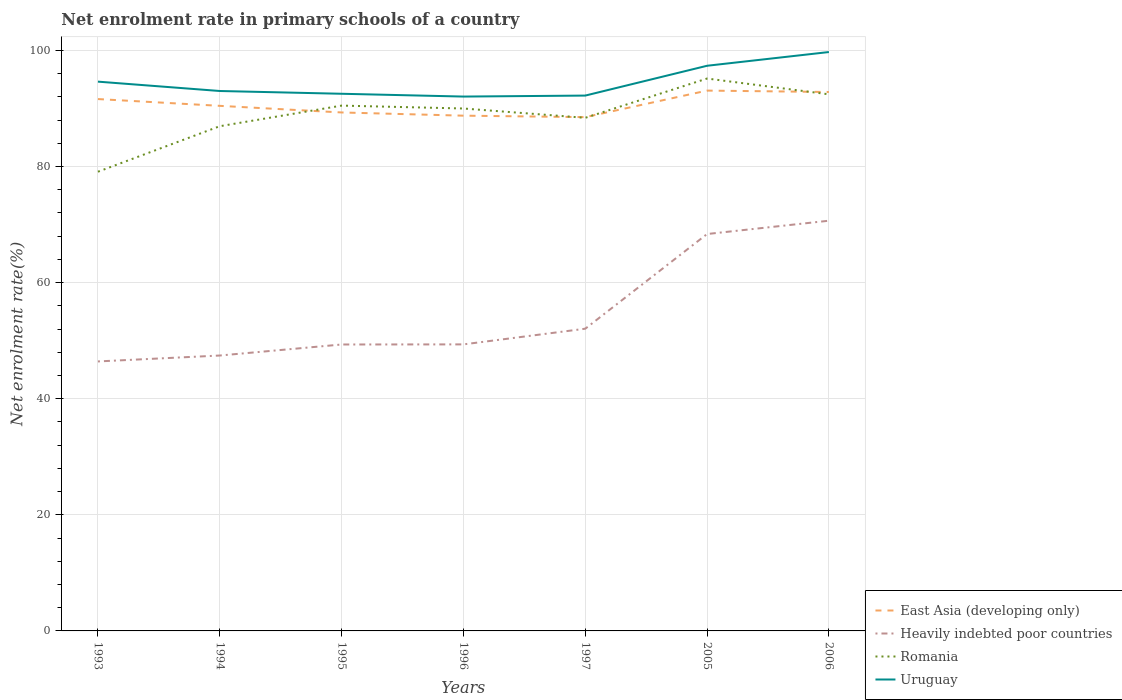How many different coloured lines are there?
Offer a very short reply. 4. Across all years, what is the maximum net enrolment rate in primary schools in Romania?
Offer a very short reply. 79.11. In which year was the net enrolment rate in primary schools in Heavily indebted poor countries maximum?
Ensure brevity in your answer.  1993. What is the total net enrolment rate in primary schools in Heavily indebted poor countries in the graph?
Offer a terse response. -1.9. What is the difference between the highest and the second highest net enrolment rate in primary schools in Uruguay?
Make the answer very short. 7.67. What is the difference between the highest and the lowest net enrolment rate in primary schools in Romania?
Your answer should be compact. 4. What is the difference between two consecutive major ticks on the Y-axis?
Offer a terse response. 20. Are the values on the major ticks of Y-axis written in scientific E-notation?
Provide a short and direct response. No. Does the graph contain grids?
Give a very brief answer. Yes. What is the title of the graph?
Your answer should be very brief. Net enrolment rate in primary schools of a country. Does "Latin America(all income levels)" appear as one of the legend labels in the graph?
Give a very brief answer. No. What is the label or title of the X-axis?
Your answer should be very brief. Years. What is the label or title of the Y-axis?
Your answer should be compact. Net enrolment rate(%). What is the Net enrolment rate(%) of East Asia (developing only) in 1993?
Keep it short and to the point. 91.63. What is the Net enrolment rate(%) of Heavily indebted poor countries in 1993?
Your response must be concise. 46.43. What is the Net enrolment rate(%) of Romania in 1993?
Keep it short and to the point. 79.11. What is the Net enrolment rate(%) of Uruguay in 1993?
Offer a very short reply. 94.63. What is the Net enrolment rate(%) in East Asia (developing only) in 1994?
Make the answer very short. 90.46. What is the Net enrolment rate(%) of Heavily indebted poor countries in 1994?
Your answer should be compact. 47.45. What is the Net enrolment rate(%) of Romania in 1994?
Your response must be concise. 86.95. What is the Net enrolment rate(%) in Uruguay in 1994?
Your response must be concise. 93.01. What is the Net enrolment rate(%) in East Asia (developing only) in 1995?
Give a very brief answer. 89.32. What is the Net enrolment rate(%) of Heavily indebted poor countries in 1995?
Keep it short and to the point. 49.34. What is the Net enrolment rate(%) in Romania in 1995?
Provide a succinct answer. 90.5. What is the Net enrolment rate(%) of Uruguay in 1995?
Your response must be concise. 92.54. What is the Net enrolment rate(%) in East Asia (developing only) in 1996?
Give a very brief answer. 88.77. What is the Net enrolment rate(%) in Heavily indebted poor countries in 1996?
Give a very brief answer. 49.36. What is the Net enrolment rate(%) in Romania in 1996?
Ensure brevity in your answer.  90. What is the Net enrolment rate(%) in Uruguay in 1996?
Give a very brief answer. 92.06. What is the Net enrolment rate(%) in East Asia (developing only) in 1997?
Offer a very short reply. 88.51. What is the Net enrolment rate(%) in Heavily indebted poor countries in 1997?
Provide a succinct answer. 52.06. What is the Net enrolment rate(%) of Romania in 1997?
Keep it short and to the point. 88.39. What is the Net enrolment rate(%) of Uruguay in 1997?
Make the answer very short. 92.22. What is the Net enrolment rate(%) of East Asia (developing only) in 2005?
Provide a succinct answer. 93.09. What is the Net enrolment rate(%) in Heavily indebted poor countries in 2005?
Give a very brief answer. 68.38. What is the Net enrolment rate(%) in Romania in 2005?
Ensure brevity in your answer.  95.16. What is the Net enrolment rate(%) in Uruguay in 2005?
Your answer should be very brief. 97.36. What is the Net enrolment rate(%) in East Asia (developing only) in 2006?
Offer a very short reply. 92.84. What is the Net enrolment rate(%) in Heavily indebted poor countries in 2006?
Your answer should be compact. 70.67. What is the Net enrolment rate(%) of Romania in 2006?
Your answer should be compact. 92.44. What is the Net enrolment rate(%) of Uruguay in 2006?
Your answer should be compact. 99.73. Across all years, what is the maximum Net enrolment rate(%) in East Asia (developing only)?
Make the answer very short. 93.09. Across all years, what is the maximum Net enrolment rate(%) in Heavily indebted poor countries?
Offer a very short reply. 70.67. Across all years, what is the maximum Net enrolment rate(%) of Romania?
Your answer should be very brief. 95.16. Across all years, what is the maximum Net enrolment rate(%) in Uruguay?
Offer a terse response. 99.73. Across all years, what is the minimum Net enrolment rate(%) of East Asia (developing only)?
Give a very brief answer. 88.51. Across all years, what is the minimum Net enrolment rate(%) in Heavily indebted poor countries?
Keep it short and to the point. 46.43. Across all years, what is the minimum Net enrolment rate(%) in Romania?
Offer a terse response. 79.11. Across all years, what is the minimum Net enrolment rate(%) of Uruguay?
Your response must be concise. 92.06. What is the total Net enrolment rate(%) of East Asia (developing only) in the graph?
Ensure brevity in your answer.  634.61. What is the total Net enrolment rate(%) in Heavily indebted poor countries in the graph?
Provide a short and direct response. 383.68. What is the total Net enrolment rate(%) in Romania in the graph?
Offer a terse response. 622.55. What is the total Net enrolment rate(%) in Uruguay in the graph?
Ensure brevity in your answer.  661.55. What is the difference between the Net enrolment rate(%) in East Asia (developing only) in 1993 and that in 1994?
Make the answer very short. 1.17. What is the difference between the Net enrolment rate(%) in Heavily indebted poor countries in 1993 and that in 1994?
Your response must be concise. -1.02. What is the difference between the Net enrolment rate(%) of Romania in 1993 and that in 1994?
Your answer should be very brief. -7.84. What is the difference between the Net enrolment rate(%) in Uruguay in 1993 and that in 1994?
Make the answer very short. 1.61. What is the difference between the Net enrolment rate(%) of East Asia (developing only) in 1993 and that in 1995?
Offer a very short reply. 2.31. What is the difference between the Net enrolment rate(%) of Heavily indebted poor countries in 1993 and that in 1995?
Offer a terse response. -2.92. What is the difference between the Net enrolment rate(%) of Romania in 1993 and that in 1995?
Offer a terse response. -11.39. What is the difference between the Net enrolment rate(%) in Uruguay in 1993 and that in 1995?
Give a very brief answer. 2.09. What is the difference between the Net enrolment rate(%) of East Asia (developing only) in 1993 and that in 1996?
Your response must be concise. 2.86. What is the difference between the Net enrolment rate(%) in Heavily indebted poor countries in 1993 and that in 1996?
Offer a terse response. -2.94. What is the difference between the Net enrolment rate(%) of Romania in 1993 and that in 1996?
Your answer should be very brief. -10.89. What is the difference between the Net enrolment rate(%) in Uruguay in 1993 and that in 1996?
Offer a very short reply. 2.57. What is the difference between the Net enrolment rate(%) of East Asia (developing only) in 1993 and that in 1997?
Offer a very short reply. 3.11. What is the difference between the Net enrolment rate(%) in Heavily indebted poor countries in 1993 and that in 1997?
Offer a terse response. -5.64. What is the difference between the Net enrolment rate(%) in Romania in 1993 and that in 1997?
Keep it short and to the point. -9.29. What is the difference between the Net enrolment rate(%) of Uruguay in 1993 and that in 1997?
Provide a succinct answer. 2.4. What is the difference between the Net enrolment rate(%) of East Asia (developing only) in 1993 and that in 2005?
Offer a terse response. -1.46. What is the difference between the Net enrolment rate(%) in Heavily indebted poor countries in 1993 and that in 2005?
Give a very brief answer. -21.95. What is the difference between the Net enrolment rate(%) in Romania in 1993 and that in 2005?
Provide a short and direct response. -16.05. What is the difference between the Net enrolment rate(%) in Uruguay in 1993 and that in 2005?
Provide a succinct answer. -2.74. What is the difference between the Net enrolment rate(%) in East Asia (developing only) in 1993 and that in 2006?
Give a very brief answer. -1.22. What is the difference between the Net enrolment rate(%) of Heavily indebted poor countries in 1993 and that in 2006?
Give a very brief answer. -24.24. What is the difference between the Net enrolment rate(%) in Romania in 1993 and that in 2006?
Ensure brevity in your answer.  -13.33. What is the difference between the Net enrolment rate(%) of Uruguay in 1993 and that in 2006?
Offer a terse response. -5.1. What is the difference between the Net enrolment rate(%) in East Asia (developing only) in 1994 and that in 1995?
Your answer should be very brief. 1.14. What is the difference between the Net enrolment rate(%) in Heavily indebted poor countries in 1994 and that in 1995?
Your answer should be compact. -1.9. What is the difference between the Net enrolment rate(%) of Romania in 1994 and that in 1995?
Give a very brief answer. -3.55. What is the difference between the Net enrolment rate(%) of Uruguay in 1994 and that in 1995?
Offer a terse response. 0.47. What is the difference between the Net enrolment rate(%) of East Asia (developing only) in 1994 and that in 1996?
Your answer should be very brief. 1.69. What is the difference between the Net enrolment rate(%) of Heavily indebted poor countries in 1994 and that in 1996?
Offer a terse response. -1.92. What is the difference between the Net enrolment rate(%) of Romania in 1994 and that in 1996?
Your response must be concise. -3.05. What is the difference between the Net enrolment rate(%) of Uruguay in 1994 and that in 1996?
Keep it short and to the point. 0.96. What is the difference between the Net enrolment rate(%) in East Asia (developing only) in 1994 and that in 1997?
Give a very brief answer. 1.95. What is the difference between the Net enrolment rate(%) of Heavily indebted poor countries in 1994 and that in 1997?
Offer a terse response. -4.62. What is the difference between the Net enrolment rate(%) of Romania in 1994 and that in 1997?
Provide a succinct answer. -1.45. What is the difference between the Net enrolment rate(%) of Uruguay in 1994 and that in 1997?
Provide a short and direct response. 0.79. What is the difference between the Net enrolment rate(%) in East Asia (developing only) in 1994 and that in 2005?
Offer a very short reply. -2.63. What is the difference between the Net enrolment rate(%) in Heavily indebted poor countries in 1994 and that in 2005?
Your response must be concise. -20.93. What is the difference between the Net enrolment rate(%) in Romania in 1994 and that in 2005?
Provide a succinct answer. -8.21. What is the difference between the Net enrolment rate(%) in Uruguay in 1994 and that in 2005?
Offer a very short reply. -4.35. What is the difference between the Net enrolment rate(%) of East Asia (developing only) in 1994 and that in 2006?
Provide a succinct answer. -2.39. What is the difference between the Net enrolment rate(%) of Heavily indebted poor countries in 1994 and that in 2006?
Your response must be concise. -23.22. What is the difference between the Net enrolment rate(%) in Romania in 1994 and that in 2006?
Make the answer very short. -5.49. What is the difference between the Net enrolment rate(%) of Uruguay in 1994 and that in 2006?
Offer a very short reply. -6.71. What is the difference between the Net enrolment rate(%) of East Asia (developing only) in 1995 and that in 1996?
Ensure brevity in your answer.  0.55. What is the difference between the Net enrolment rate(%) in Heavily indebted poor countries in 1995 and that in 1996?
Your answer should be very brief. -0.02. What is the difference between the Net enrolment rate(%) in Romania in 1995 and that in 1996?
Ensure brevity in your answer.  0.5. What is the difference between the Net enrolment rate(%) in Uruguay in 1995 and that in 1996?
Offer a very short reply. 0.48. What is the difference between the Net enrolment rate(%) in East Asia (developing only) in 1995 and that in 1997?
Make the answer very short. 0.81. What is the difference between the Net enrolment rate(%) of Heavily indebted poor countries in 1995 and that in 1997?
Provide a succinct answer. -2.72. What is the difference between the Net enrolment rate(%) in Romania in 1995 and that in 1997?
Give a very brief answer. 2.1. What is the difference between the Net enrolment rate(%) of Uruguay in 1995 and that in 1997?
Make the answer very short. 0.31. What is the difference between the Net enrolment rate(%) in East Asia (developing only) in 1995 and that in 2005?
Keep it short and to the point. -3.77. What is the difference between the Net enrolment rate(%) in Heavily indebted poor countries in 1995 and that in 2005?
Offer a terse response. -19.03. What is the difference between the Net enrolment rate(%) in Romania in 1995 and that in 2005?
Provide a short and direct response. -4.66. What is the difference between the Net enrolment rate(%) in Uruguay in 1995 and that in 2005?
Your response must be concise. -4.82. What is the difference between the Net enrolment rate(%) in East Asia (developing only) in 1995 and that in 2006?
Your answer should be compact. -3.53. What is the difference between the Net enrolment rate(%) of Heavily indebted poor countries in 1995 and that in 2006?
Give a very brief answer. -21.32. What is the difference between the Net enrolment rate(%) in Romania in 1995 and that in 2006?
Give a very brief answer. -1.94. What is the difference between the Net enrolment rate(%) in Uruguay in 1995 and that in 2006?
Give a very brief answer. -7.19. What is the difference between the Net enrolment rate(%) in East Asia (developing only) in 1996 and that in 1997?
Your answer should be compact. 0.25. What is the difference between the Net enrolment rate(%) of Heavily indebted poor countries in 1996 and that in 1997?
Provide a succinct answer. -2.7. What is the difference between the Net enrolment rate(%) in Romania in 1996 and that in 1997?
Provide a short and direct response. 1.61. What is the difference between the Net enrolment rate(%) of Uruguay in 1996 and that in 1997?
Provide a short and direct response. -0.17. What is the difference between the Net enrolment rate(%) in East Asia (developing only) in 1996 and that in 2005?
Offer a terse response. -4.32. What is the difference between the Net enrolment rate(%) in Heavily indebted poor countries in 1996 and that in 2005?
Keep it short and to the point. -19.01. What is the difference between the Net enrolment rate(%) of Romania in 1996 and that in 2005?
Your answer should be compact. -5.16. What is the difference between the Net enrolment rate(%) of Uruguay in 1996 and that in 2005?
Keep it short and to the point. -5.31. What is the difference between the Net enrolment rate(%) in East Asia (developing only) in 1996 and that in 2006?
Your answer should be compact. -4.08. What is the difference between the Net enrolment rate(%) of Heavily indebted poor countries in 1996 and that in 2006?
Make the answer very short. -21.3. What is the difference between the Net enrolment rate(%) of Romania in 1996 and that in 2006?
Provide a short and direct response. -2.44. What is the difference between the Net enrolment rate(%) of Uruguay in 1996 and that in 2006?
Keep it short and to the point. -7.67. What is the difference between the Net enrolment rate(%) in East Asia (developing only) in 1997 and that in 2005?
Provide a succinct answer. -4.57. What is the difference between the Net enrolment rate(%) of Heavily indebted poor countries in 1997 and that in 2005?
Your response must be concise. -16.31. What is the difference between the Net enrolment rate(%) of Romania in 1997 and that in 2005?
Your answer should be compact. -6.77. What is the difference between the Net enrolment rate(%) of Uruguay in 1997 and that in 2005?
Your answer should be compact. -5.14. What is the difference between the Net enrolment rate(%) in East Asia (developing only) in 1997 and that in 2006?
Keep it short and to the point. -4.33. What is the difference between the Net enrolment rate(%) in Heavily indebted poor countries in 1997 and that in 2006?
Your answer should be very brief. -18.61. What is the difference between the Net enrolment rate(%) of Romania in 1997 and that in 2006?
Your answer should be compact. -4.05. What is the difference between the Net enrolment rate(%) of Uruguay in 1997 and that in 2006?
Provide a short and direct response. -7.5. What is the difference between the Net enrolment rate(%) in East Asia (developing only) in 2005 and that in 2006?
Offer a very short reply. 0.24. What is the difference between the Net enrolment rate(%) of Heavily indebted poor countries in 2005 and that in 2006?
Your answer should be compact. -2.29. What is the difference between the Net enrolment rate(%) of Romania in 2005 and that in 2006?
Your response must be concise. 2.72. What is the difference between the Net enrolment rate(%) of Uruguay in 2005 and that in 2006?
Your answer should be compact. -2.36. What is the difference between the Net enrolment rate(%) of East Asia (developing only) in 1993 and the Net enrolment rate(%) of Heavily indebted poor countries in 1994?
Provide a short and direct response. 44.18. What is the difference between the Net enrolment rate(%) in East Asia (developing only) in 1993 and the Net enrolment rate(%) in Romania in 1994?
Your answer should be very brief. 4.68. What is the difference between the Net enrolment rate(%) of East Asia (developing only) in 1993 and the Net enrolment rate(%) of Uruguay in 1994?
Ensure brevity in your answer.  -1.39. What is the difference between the Net enrolment rate(%) of Heavily indebted poor countries in 1993 and the Net enrolment rate(%) of Romania in 1994?
Offer a very short reply. -40.52. What is the difference between the Net enrolment rate(%) in Heavily indebted poor countries in 1993 and the Net enrolment rate(%) in Uruguay in 1994?
Provide a succinct answer. -46.59. What is the difference between the Net enrolment rate(%) of Romania in 1993 and the Net enrolment rate(%) of Uruguay in 1994?
Your response must be concise. -13.9. What is the difference between the Net enrolment rate(%) in East Asia (developing only) in 1993 and the Net enrolment rate(%) in Heavily indebted poor countries in 1995?
Provide a succinct answer. 42.28. What is the difference between the Net enrolment rate(%) in East Asia (developing only) in 1993 and the Net enrolment rate(%) in Romania in 1995?
Provide a succinct answer. 1.13. What is the difference between the Net enrolment rate(%) of East Asia (developing only) in 1993 and the Net enrolment rate(%) of Uruguay in 1995?
Keep it short and to the point. -0.91. What is the difference between the Net enrolment rate(%) of Heavily indebted poor countries in 1993 and the Net enrolment rate(%) of Romania in 1995?
Your response must be concise. -44.07. What is the difference between the Net enrolment rate(%) in Heavily indebted poor countries in 1993 and the Net enrolment rate(%) in Uruguay in 1995?
Offer a very short reply. -46.11. What is the difference between the Net enrolment rate(%) in Romania in 1993 and the Net enrolment rate(%) in Uruguay in 1995?
Offer a terse response. -13.43. What is the difference between the Net enrolment rate(%) of East Asia (developing only) in 1993 and the Net enrolment rate(%) of Heavily indebted poor countries in 1996?
Offer a very short reply. 42.26. What is the difference between the Net enrolment rate(%) of East Asia (developing only) in 1993 and the Net enrolment rate(%) of Romania in 1996?
Provide a short and direct response. 1.63. What is the difference between the Net enrolment rate(%) of East Asia (developing only) in 1993 and the Net enrolment rate(%) of Uruguay in 1996?
Your answer should be compact. -0.43. What is the difference between the Net enrolment rate(%) of Heavily indebted poor countries in 1993 and the Net enrolment rate(%) of Romania in 1996?
Keep it short and to the point. -43.57. What is the difference between the Net enrolment rate(%) in Heavily indebted poor countries in 1993 and the Net enrolment rate(%) in Uruguay in 1996?
Your response must be concise. -45.63. What is the difference between the Net enrolment rate(%) of Romania in 1993 and the Net enrolment rate(%) of Uruguay in 1996?
Your answer should be very brief. -12.95. What is the difference between the Net enrolment rate(%) in East Asia (developing only) in 1993 and the Net enrolment rate(%) in Heavily indebted poor countries in 1997?
Give a very brief answer. 39.56. What is the difference between the Net enrolment rate(%) of East Asia (developing only) in 1993 and the Net enrolment rate(%) of Romania in 1997?
Make the answer very short. 3.23. What is the difference between the Net enrolment rate(%) of East Asia (developing only) in 1993 and the Net enrolment rate(%) of Uruguay in 1997?
Offer a terse response. -0.6. What is the difference between the Net enrolment rate(%) in Heavily indebted poor countries in 1993 and the Net enrolment rate(%) in Romania in 1997?
Your response must be concise. -41.97. What is the difference between the Net enrolment rate(%) in Heavily indebted poor countries in 1993 and the Net enrolment rate(%) in Uruguay in 1997?
Offer a terse response. -45.8. What is the difference between the Net enrolment rate(%) of Romania in 1993 and the Net enrolment rate(%) of Uruguay in 1997?
Give a very brief answer. -13.12. What is the difference between the Net enrolment rate(%) in East Asia (developing only) in 1993 and the Net enrolment rate(%) in Heavily indebted poor countries in 2005?
Your response must be concise. 23.25. What is the difference between the Net enrolment rate(%) in East Asia (developing only) in 1993 and the Net enrolment rate(%) in Romania in 2005?
Offer a very short reply. -3.54. What is the difference between the Net enrolment rate(%) in East Asia (developing only) in 1993 and the Net enrolment rate(%) in Uruguay in 2005?
Your answer should be very brief. -5.74. What is the difference between the Net enrolment rate(%) in Heavily indebted poor countries in 1993 and the Net enrolment rate(%) in Romania in 2005?
Offer a very short reply. -48.74. What is the difference between the Net enrolment rate(%) in Heavily indebted poor countries in 1993 and the Net enrolment rate(%) in Uruguay in 2005?
Ensure brevity in your answer.  -50.94. What is the difference between the Net enrolment rate(%) in Romania in 1993 and the Net enrolment rate(%) in Uruguay in 2005?
Give a very brief answer. -18.25. What is the difference between the Net enrolment rate(%) of East Asia (developing only) in 1993 and the Net enrolment rate(%) of Heavily indebted poor countries in 2006?
Offer a very short reply. 20.96. What is the difference between the Net enrolment rate(%) of East Asia (developing only) in 1993 and the Net enrolment rate(%) of Romania in 2006?
Provide a short and direct response. -0.82. What is the difference between the Net enrolment rate(%) of East Asia (developing only) in 1993 and the Net enrolment rate(%) of Uruguay in 2006?
Your answer should be compact. -8.1. What is the difference between the Net enrolment rate(%) of Heavily indebted poor countries in 1993 and the Net enrolment rate(%) of Romania in 2006?
Keep it short and to the point. -46.02. What is the difference between the Net enrolment rate(%) in Heavily indebted poor countries in 1993 and the Net enrolment rate(%) in Uruguay in 2006?
Make the answer very short. -53.3. What is the difference between the Net enrolment rate(%) in Romania in 1993 and the Net enrolment rate(%) in Uruguay in 2006?
Your answer should be compact. -20.62. What is the difference between the Net enrolment rate(%) of East Asia (developing only) in 1994 and the Net enrolment rate(%) of Heavily indebted poor countries in 1995?
Provide a succinct answer. 41.11. What is the difference between the Net enrolment rate(%) in East Asia (developing only) in 1994 and the Net enrolment rate(%) in Romania in 1995?
Offer a terse response. -0.04. What is the difference between the Net enrolment rate(%) in East Asia (developing only) in 1994 and the Net enrolment rate(%) in Uruguay in 1995?
Give a very brief answer. -2.08. What is the difference between the Net enrolment rate(%) in Heavily indebted poor countries in 1994 and the Net enrolment rate(%) in Romania in 1995?
Your response must be concise. -43.05. What is the difference between the Net enrolment rate(%) of Heavily indebted poor countries in 1994 and the Net enrolment rate(%) of Uruguay in 1995?
Your response must be concise. -45.09. What is the difference between the Net enrolment rate(%) in Romania in 1994 and the Net enrolment rate(%) in Uruguay in 1995?
Provide a succinct answer. -5.59. What is the difference between the Net enrolment rate(%) of East Asia (developing only) in 1994 and the Net enrolment rate(%) of Heavily indebted poor countries in 1996?
Give a very brief answer. 41.09. What is the difference between the Net enrolment rate(%) of East Asia (developing only) in 1994 and the Net enrolment rate(%) of Romania in 1996?
Your answer should be very brief. 0.46. What is the difference between the Net enrolment rate(%) of East Asia (developing only) in 1994 and the Net enrolment rate(%) of Uruguay in 1996?
Provide a succinct answer. -1.6. What is the difference between the Net enrolment rate(%) in Heavily indebted poor countries in 1994 and the Net enrolment rate(%) in Romania in 1996?
Offer a terse response. -42.55. What is the difference between the Net enrolment rate(%) of Heavily indebted poor countries in 1994 and the Net enrolment rate(%) of Uruguay in 1996?
Ensure brevity in your answer.  -44.61. What is the difference between the Net enrolment rate(%) in Romania in 1994 and the Net enrolment rate(%) in Uruguay in 1996?
Provide a short and direct response. -5.11. What is the difference between the Net enrolment rate(%) in East Asia (developing only) in 1994 and the Net enrolment rate(%) in Heavily indebted poor countries in 1997?
Provide a succinct answer. 38.4. What is the difference between the Net enrolment rate(%) in East Asia (developing only) in 1994 and the Net enrolment rate(%) in Romania in 1997?
Offer a terse response. 2.06. What is the difference between the Net enrolment rate(%) of East Asia (developing only) in 1994 and the Net enrolment rate(%) of Uruguay in 1997?
Your response must be concise. -1.77. What is the difference between the Net enrolment rate(%) of Heavily indebted poor countries in 1994 and the Net enrolment rate(%) of Romania in 1997?
Make the answer very short. -40.95. What is the difference between the Net enrolment rate(%) in Heavily indebted poor countries in 1994 and the Net enrolment rate(%) in Uruguay in 1997?
Your answer should be very brief. -44.78. What is the difference between the Net enrolment rate(%) in Romania in 1994 and the Net enrolment rate(%) in Uruguay in 1997?
Provide a succinct answer. -5.28. What is the difference between the Net enrolment rate(%) of East Asia (developing only) in 1994 and the Net enrolment rate(%) of Heavily indebted poor countries in 2005?
Your response must be concise. 22.08. What is the difference between the Net enrolment rate(%) of East Asia (developing only) in 1994 and the Net enrolment rate(%) of Romania in 2005?
Give a very brief answer. -4.7. What is the difference between the Net enrolment rate(%) in East Asia (developing only) in 1994 and the Net enrolment rate(%) in Uruguay in 2005?
Offer a very short reply. -6.9. What is the difference between the Net enrolment rate(%) in Heavily indebted poor countries in 1994 and the Net enrolment rate(%) in Romania in 2005?
Provide a short and direct response. -47.72. What is the difference between the Net enrolment rate(%) of Heavily indebted poor countries in 1994 and the Net enrolment rate(%) of Uruguay in 2005?
Keep it short and to the point. -49.92. What is the difference between the Net enrolment rate(%) of Romania in 1994 and the Net enrolment rate(%) of Uruguay in 2005?
Your response must be concise. -10.41. What is the difference between the Net enrolment rate(%) in East Asia (developing only) in 1994 and the Net enrolment rate(%) in Heavily indebted poor countries in 2006?
Your answer should be very brief. 19.79. What is the difference between the Net enrolment rate(%) in East Asia (developing only) in 1994 and the Net enrolment rate(%) in Romania in 2006?
Offer a terse response. -1.98. What is the difference between the Net enrolment rate(%) of East Asia (developing only) in 1994 and the Net enrolment rate(%) of Uruguay in 2006?
Offer a terse response. -9.27. What is the difference between the Net enrolment rate(%) in Heavily indebted poor countries in 1994 and the Net enrolment rate(%) in Romania in 2006?
Ensure brevity in your answer.  -45. What is the difference between the Net enrolment rate(%) in Heavily indebted poor countries in 1994 and the Net enrolment rate(%) in Uruguay in 2006?
Ensure brevity in your answer.  -52.28. What is the difference between the Net enrolment rate(%) in Romania in 1994 and the Net enrolment rate(%) in Uruguay in 2006?
Your answer should be compact. -12.78. What is the difference between the Net enrolment rate(%) in East Asia (developing only) in 1995 and the Net enrolment rate(%) in Heavily indebted poor countries in 1996?
Provide a short and direct response. 39.95. What is the difference between the Net enrolment rate(%) of East Asia (developing only) in 1995 and the Net enrolment rate(%) of Romania in 1996?
Offer a very short reply. -0.68. What is the difference between the Net enrolment rate(%) in East Asia (developing only) in 1995 and the Net enrolment rate(%) in Uruguay in 1996?
Offer a very short reply. -2.74. What is the difference between the Net enrolment rate(%) of Heavily indebted poor countries in 1995 and the Net enrolment rate(%) of Romania in 1996?
Offer a terse response. -40.66. What is the difference between the Net enrolment rate(%) of Heavily indebted poor countries in 1995 and the Net enrolment rate(%) of Uruguay in 1996?
Provide a short and direct response. -42.71. What is the difference between the Net enrolment rate(%) of Romania in 1995 and the Net enrolment rate(%) of Uruguay in 1996?
Your answer should be compact. -1.56. What is the difference between the Net enrolment rate(%) of East Asia (developing only) in 1995 and the Net enrolment rate(%) of Heavily indebted poor countries in 1997?
Give a very brief answer. 37.26. What is the difference between the Net enrolment rate(%) of East Asia (developing only) in 1995 and the Net enrolment rate(%) of Romania in 1997?
Offer a terse response. 0.92. What is the difference between the Net enrolment rate(%) of East Asia (developing only) in 1995 and the Net enrolment rate(%) of Uruguay in 1997?
Keep it short and to the point. -2.91. What is the difference between the Net enrolment rate(%) in Heavily indebted poor countries in 1995 and the Net enrolment rate(%) in Romania in 1997?
Provide a succinct answer. -39.05. What is the difference between the Net enrolment rate(%) of Heavily indebted poor countries in 1995 and the Net enrolment rate(%) of Uruguay in 1997?
Provide a succinct answer. -42.88. What is the difference between the Net enrolment rate(%) of Romania in 1995 and the Net enrolment rate(%) of Uruguay in 1997?
Make the answer very short. -1.73. What is the difference between the Net enrolment rate(%) of East Asia (developing only) in 1995 and the Net enrolment rate(%) of Heavily indebted poor countries in 2005?
Your answer should be compact. 20.94. What is the difference between the Net enrolment rate(%) of East Asia (developing only) in 1995 and the Net enrolment rate(%) of Romania in 2005?
Your answer should be compact. -5.84. What is the difference between the Net enrolment rate(%) of East Asia (developing only) in 1995 and the Net enrolment rate(%) of Uruguay in 2005?
Ensure brevity in your answer.  -8.05. What is the difference between the Net enrolment rate(%) of Heavily indebted poor countries in 1995 and the Net enrolment rate(%) of Romania in 2005?
Your answer should be compact. -45.82. What is the difference between the Net enrolment rate(%) in Heavily indebted poor countries in 1995 and the Net enrolment rate(%) in Uruguay in 2005?
Your response must be concise. -48.02. What is the difference between the Net enrolment rate(%) in Romania in 1995 and the Net enrolment rate(%) in Uruguay in 2005?
Offer a very short reply. -6.86. What is the difference between the Net enrolment rate(%) in East Asia (developing only) in 1995 and the Net enrolment rate(%) in Heavily indebted poor countries in 2006?
Ensure brevity in your answer.  18.65. What is the difference between the Net enrolment rate(%) of East Asia (developing only) in 1995 and the Net enrolment rate(%) of Romania in 2006?
Provide a succinct answer. -3.12. What is the difference between the Net enrolment rate(%) of East Asia (developing only) in 1995 and the Net enrolment rate(%) of Uruguay in 2006?
Keep it short and to the point. -10.41. What is the difference between the Net enrolment rate(%) in Heavily indebted poor countries in 1995 and the Net enrolment rate(%) in Romania in 2006?
Give a very brief answer. -43.1. What is the difference between the Net enrolment rate(%) of Heavily indebted poor countries in 1995 and the Net enrolment rate(%) of Uruguay in 2006?
Your response must be concise. -50.38. What is the difference between the Net enrolment rate(%) in Romania in 1995 and the Net enrolment rate(%) in Uruguay in 2006?
Make the answer very short. -9.23. What is the difference between the Net enrolment rate(%) in East Asia (developing only) in 1996 and the Net enrolment rate(%) in Heavily indebted poor countries in 1997?
Ensure brevity in your answer.  36.7. What is the difference between the Net enrolment rate(%) in East Asia (developing only) in 1996 and the Net enrolment rate(%) in Romania in 1997?
Your answer should be compact. 0.37. What is the difference between the Net enrolment rate(%) of East Asia (developing only) in 1996 and the Net enrolment rate(%) of Uruguay in 1997?
Keep it short and to the point. -3.46. What is the difference between the Net enrolment rate(%) in Heavily indebted poor countries in 1996 and the Net enrolment rate(%) in Romania in 1997?
Provide a short and direct response. -39.03. What is the difference between the Net enrolment rate(%) of Heavily indebted poor countries in 1996 and the Net enrolment rate(%) of Uruguay in 1997?
Offer a very short reply. -42.86. What is the difference between the Net enrolment rate(%) in Romania in 1996 and the Net enrolment rate(%) in Uruguay in 1997?
Make the answer very short. -2.23. What is the difference between the Net enrolment rate(%) in East Asia (developing only) in 1996 and the Net enrolment rate(%) in Heavily indebted poor countries in 2005?
Your answer should be very brief. 20.39. What is the difference between the Net enrolment rate(%) in East Asia (developing only) in 1996 and the Net enrolment rate(%) in Romania in 2005?
Offer a very short reply. -6.4. What is the difference between the Net enrolment rate(%) in East Asia (developing only) in 1996 and the Net enrolment rate(%) in Uruguay in 2005?
Your answer should be compact. -8.6. What is the difference between the Net enrolment rate(%) in Heavily indebted poor countries in 1996 and the Net enrolment rate(%) in Romania in 2005?
Offer a very short reply. -45.8. What is the difference between the Net enrolment rate(%) of Heavily indebted poor countries in 1996 and the Net enrolment rate(%) of Uruguay in 2005?
Your answer should be compact. -48. What is the difference between the Net enrolment rate(%) in Romania in 1996 and the Net enrolment rate(%) in Uruguay in 2005?
Make the answer very short. -7.36. What is the difference between the Net enrolment rate(%) in East Asia (developing only) in 1996 and the Net enrolment rate(%) in Heavily indebted poor countries in 2006?
Provide a succinct answer. 18.1. What is the difference between the Net enrolment rate(%) of East Asia (developing only) in 1996 and the Net enrolment rate(%) of Romania in 2006?
Make the answer very short. -3.68. What is the difference between the Net enrolment rate(%) in East Asia (developing only) in 1996 and the Net enrolment rate(%) in Uruguay in 2006?
Provide a succinct answer. -10.96. What is the difference between the Net enrolment rate(%) in Heavily indebted poor countries in 1996 and the Net enrolment rate(%) in Romania in 2006?
Offer a terse response. -43.08. What is the difference between the Net enrolment rate(%) of Heavily indebted poor countries in 1996 and the Net enrolment rate(%) of Uruguay in 2006?
Your answer should be compact. -50.36. What is the difference between the Net enrolment rate(%) of Romania in 1996 and the Net enrolment rate(%) of Uruguay in 2006?
Offer a very short reply. -9.73. What is the difference between the Net enrolment rate(%) of East Asia (developing only) in 1997 and the Net enrolment rate(%) of Heavily indebted poor countries in 2005?
Provide a short and direct response. 20.14. What is the difference between the Net enrolment rate(%) in East Asia (developing only) in 1997 and the Net enrolment rate(%) in Romania in 2005?
Give a very brief answer. -6.65. What is the difference between the Net enrolment rate(%) of East Asia (developing only) in 1997 and the Net enrolment rate(%) of Uruguay in 2005?
Provide a short and direct response. -8.85. What is the difference between the Net enrolment rate(%) of Heavily indebted poor countries in 1997 and the Net enrolment rate(%) of Romania in 2005?
Provide a succinct answer. -43.1. What is the difference between the Net enrolment rate(%) of Heavily indebted poor countries in 1997 and the Net enrolment rate(%) of Uruguay in 2005?
Provide a short and direct response. -45.3. What is the difference between the Net enrolment rate(%) of Romania in 1997 and the Net enrolment rate(%) of Uruguay in 2005?
Give a very brief answer. -8.97. What is the difference between the Net enrolment rate(%) of East Asia (developing only) in 1997 and the Net enrolment rate(%) of Heavily indebted poor countries in 2006?
Ensure brevity in your answer.  17.84. What is the difference between the Net enrolment rate(%) in East Asia (developing only) in 1997 and the Net enrolment rate(%) in Romania in 2006?
Ensure brevity in your answer.  -3.93. What is the difference between the Net enrolment rate(%) of East Asia (developing only) in 1997 and the Net enrolment rate(%) of Uruguay in 2006?
Offer a terse response. -11.21. What is the difference between the Net enrolment rate(%) in Heavily indebted poor countries in 1997 and the Net enrolment rate(%) in Romania in 2006?
Your response must be concise. -40.38. What is the difference between the Net enrolment rate(%) of Heavily indebted poor countries in 1997 and the Net enrolment rate(%) of Uruguay in 2006?
Your response must be concise. -47.66. What is the difference between the Net enrolment rate(%) of Romania in 1997 and the Net enrolment rate(%) of Uruguay in 2006?
Your answer should be very brief. -11.33. What is the difference between the Net enrolment rate(%) of East Asia (developing only) in 2005 and the Net enrolment rate(%) of Heavily indebted poor countries in 2006?
Your answer should be very brief. 22.42. What is the difference between the Net enrolment rate(%) of East Asia (developing only) in 2005 and the Net enrolment rate(%) of Romania in 2006?
Provide a short and direct response. 0.64. What is the difference between the Net enrolment rate(%) in East Asia (developing only) in 2005 and the Net enrolment rate(%) in Uruguay in 2006?
Keep it short and to the point. -6.64. What is the difference between the Net enrolment rate(%) of Heavily indebted poor countries in 2005 and the Net enrolment rate(%) of Romania in 2006?
Your answer should be compact. -24.07. What is the difference between the Net enrolment rate(%) in Heavily indebted poor countries in 2005 and the Net enrolment rate(%) in Uruguay in 2006?
Give a very brief answer. -31.35. What is the difference between the Net enrolment rate(%) in Romania in 2005 and the Net enrolment rate(%) in Uruguay in 2006?
Your answer should be compact. -4.56. What is the average Net enrolment rate(%) of East Asia (developing only) per year?
Your answer should be very brief. 90.66. What is the average Net enrolment rate(%) of Heavily indebted poor countries per year?
Provide a short and direct response. 54.81. What is the average Net enrolment rate(%) of Romania per year?
Your answer should be compact. 88.94. What is the average Net enrolment rate(%) in Uruguay per year?
Offer a very short reply. 94.51. In the year 1993, what is the difference between the Net enrolment rate(%) of East Asia (developing only) and Net enrolment rate(%) of Heavily indebted poor countries?
Ensure brevity in your answer.  45.2. In the year 1993, what is the difference between the Net enrolment rate(%) of East Asia (developing only) and Net enrolment rate(%) of Romania?
Your answer should be very brief. 12.52. In the year 1993, what is the difference between the Net enrolment rate(%) of East Asia (developing only) and Net enrolment rate(%) of Uruguay?
Your answer should be very brief. -3. In the year 1993, what is the difference between the Net enrolment rate(%) of Heavily indebted poor countries and Net enrolment rate(%) of Romania?
Offer a terse response. -32.68. In the year 1993, what is the difference between the Net enrolment rate(%) in Heavily indebted poor countries and Net enrolment rate(%) in Uruguay?
Give a very brief answer. -48.2. In the year 1993, what is the difference between the Net enrolment rate(%) in Romania and Net enrolment rate(%) in Uruguay?
Your answer should be very brief. -15.52. In the year 1994, what is the difference between the Net enrolment rate(%) of East Asia (developing only) and Net enrolment rate(%) of Heavily indebted poor countries?
Provide a short and direct response. 43.01. In the year 1994, what is the difference between the Net enrolment rate(%) of East Asia (developing only) and Net enrolment rate(%) of Romania?
Make the answer very short. 3.51. In the year 1994, what is the difference between the Net enrolment rate(%) in East Asia (developing only) and Net enrolment rate(%) in Uruguay?
Your answer should be compact. -2.56. In the year 1994, what is the difference between the Net enrolment rate(%) in Heavily indebted poor countries and Net enrolment rate(%) in Romania?
Your response must be concise. -39.5. In the year 1994, what is the difference between the Net enrolment rate(%) in Heavily indebted poor countries and Net enrolment rate(%) in Uruguay?
Offer a terse response. -45.57. In the year 1994, what is the difference between the Net enrolment rate(%) of Romania and Net enrolment rate(%) of Uruguay?
Offer a very short reply. -6.07. In the year 1995, what is the difference between the Net enrolment rate(%) of East Asia (developing only) and Net enrolment rate(%) of Heavily indebted poor countries?
Your answer should be compact. 39.97. In the year 1995, what is the difference between the Net enrolment rate(%) in East Asia (developing only) and Net enrolment rate(%) in Romania?
Ensure brevity in your answer.  -1.18. In the year 1995, what is the difference between the Net enrolment rate(%) of East Asia (developing only) and Net enrolment rate(%) of Uruguay?
Keep it short and to the point. -3.22. In the year 1995, what is the difference between the Net enrolment rate(%) in Heavily indebted poor countries and Net enrolment rate(%) in Romania?
Ensure brevity in your answer.  -41.15. In the year 1995, what is the difference between the Net enrolment rate(%) of Heavily indebted poor countries and Net enrolment rate(%) of Uruguay?
Ensure brevity in your answer.  -43.2. In the year 1995, what is the difference between the Net enrolment rate(%) in Romania and Net enrolment rate(%) in Uruguay?
Provide a short and direct response. -2.04. In the year 1996, what is the difference between the Net enrolment rate(%) in East Asia (developing only) and Net enrolment rate(%) in Heavily indebted poor countries?
Offer a terse response. 39.4. In the year 1996, what is the difference between the Net enrolment rate(%) in East Asia (developing only) and Net enrolment rate(%) in Romania?
Keep it short and to the point. -1.23. In the year 1996, what is the difference between the Net enrolment rate(%) in East Asia (developing only) and Net enrolment rate(%) in Uruguay?
Your answer should be very brief. -3.29. In the year 1996, what is the difference between the Net enrolment rate(%) of Heavily indebted poor countries and Net enrolment rate(%) of Romania?
Your answer should be very brief. -40.64. In the year 1996, what is the difference between the Net enrolment rate(%) of Heavily indebted poor countries and Net enrolment rate(%) of Uruguay?
Make the answer very short. -42.69. In the year 1996, what is the difference between the Net enrolment rate(%) of Romania and Net enrolment rate(%) of Uruguay?
Provide a short and direct response. -2.06. In the year 1997, what is the difference between the Net enrolment rate(%) of East Asia (developing only) and Net enrolment rate(%) of Heavily indebted poor countries?
Give a very brief answer. 36.45. In the year 1997, what is the difference between the Net enrolment rate(%) of East Asia (developing only) and Net enrolment rate(%) of Romania?
Your response must be concise. 0.12. In the year 1997, what is the difference between the Net enrolment rate(%) in East Asia (developing only) and Net enrolment rate(%) in Uruguay?
Give a very brief answer. -3.71. In the year 1997, what is the difference between the Net enrolment rate(%) of Heavily indebted poor countries and Net enrolment rate(%) of Romania?
Keep it short and to the point. -36.33. In the year 1997, what is the difference between the Net enrolment rate(%) in Heavily indebted poor countries and Net enrolment rate(%) in Uruguay?
Offer a very short reply. -40.16. In the year 1997, what is the difference between the Net enrolment rate(%) in Romania and Net enrolment rate(%) in Uruguay?
Ensure brevity in your answer.  -3.83. In the year 2005, what is the difference between the Net enrolment rate(%) in East Asia (developing only) and Net enrolment rate(%) in Heavily indebted poor countries?
Your response must be concise. 24.71. In the year 2005, what is the difference between the Net enrolment rate(%) in East Asia (developing only) and Net enrolment rate(%) in Romania?
Your answer should be very brief. -2.08. In the year 2005, what is the difference between the Net enrolment rate(%) of East Asia (developing only) and Net enrolment rate(%) of Uruguay?
Provide a succinct answer. -4.28. In the year 2005, what is the difference between the Net enrolment rate(%) in Heavily indebted poor countries and Net enrolment rate(%) in Romania?
Your answer should be compact. -26.79. In the year 2005, what is the difference between the Net enrolment rate(%) of Heavily indebted poor countries and Net enrolment rate(%) of Uruguay?
Provide a short and direct response. -28.99. In the year 2005, what is the difference between the Net enrolment rate(%) in Romania and Net enrolment rate(%) in Uruguay?
Offer a very short reply. -2.2. In the year 2006, what is the difference between the Net enrolment rate(%) in East Asia (developing only) and Net enrolment rate(%) in Heavily indebted poor countries?
Make the answer very short. 22.18. In the year 2006, what is the difference between the Net enrolment rate(%) of East Asia (developing only) and Net enrolment rate(%) of Romania?
Keep it short and to the point. 0.4. In the year 2006, what is the difference between the Net enrolment rate(%) in East Asia (developing only) and Net enrolment rate(%) in Uruguay?
Your answer should be compact. -6.88. In the year 2006, what is the difference between the Net enrolment rate(%) in Heavily indebted poor countries and Net enrolment rate(%) in Romania?
Give a very brief answer. -21.77. In the year 2006, what is the difference between the Net enrolment rate(%) in Heavily indebted poor countries and Net enrolment rate(%) in Uruguay?
Your answer should be very brief. -29.06. In the year 2006, what is the difference between the Net enrolment rate(%) in Romania and Net enrolment rate(%) in Uruguay?
Offer a very short reply. -7.28. What is the ratio of the Net enrolment rate(%) of East Asia (developing only) in 1993 to that in 1994?
Ensure brevity in your answer.  1.01. What is the ratio of the Net enrolment rate(%) in Heavily indebted poor countries in 1993 to that in 1994?
Keep it short and to the point. 0.98. What is the ratio of the Net enrolment rate(%) of Romania in 1993 to that in 1994?
Your response must be concise. 0.91. What is the ratio of the Net enrolment rate(%) in Uruguay in 1993 to that in 1994?
Your answer should be very brief. 1.02. What is the ratio of the Net enrolment rate(%) of East Asia (developing only) in 1993 to that in 1995?
Offer a terse response. 1.03. What is the ratio of the Net enrolment rate(%) of Heavily indebted poor countries in 1993 to that in 1995?
Offer a terse response. 0.94. What is the ratio of the Net enrolment rate(%) of Romania in 1993 to that in 1995?
Make the answer very short. 0.87. What is the ratio of the Net enrolment rate(%) in Uruguay in 1993 to that in 1995?
Your response must be concise. 1.02. What is the ratio of the Net enrolment rate(%) of East Asia (developing only) in 1993 to that in 1996?
Your answer should be very brief. 1.03. What is the ratio of the Net enrolment rate(%) of Heavily indebted poor countries in 1993 to that in 1996?
Ensure brevity in your answer.  0.94. What is the ratio of the Net enrolment rate(%) of Romania in 1993 to that in 1996?
Ensure brevity in your answer.  0.88. What is the ratio of the Net enrolment rate(%) of Uruguay in 1993 to that in 1996?
Your answer should be compact. 1.03. What is the ratio of the Net enrolment rate(%) in East Asia (developing only) in 1993 to that in 1997?
Your answer should be very brief. 1.04. What is the ratio of the Net enrolment rate(%) of Heavily indebted poor countries in 1993 to that in 1997?
Give a very brief answer. 0.89. What is the ratio of the Net enrolment rate(%) in Romania in 1993 to that in 1997?
Ensure brevity in your answer.  0.9. What is the ratio of the Net enrolment rate(%) of East Asia (developing only) in 1993 to that in 2005?
Your answer should be very brief. 0.98. What is the ratio of the Net enrolment rate(%) in Heavily indebted poor countries in 1993 to that in 2005?
Your response must be concise. 0.68. What is the ratio of the Net enrolment rate(%) in Romania in 1993 to that in 2005?
Provide a short and direct response. 0.83. What is the ratio of the Net enrolment rate(%) in Uruguay in 1993 to that in 2005?
Ensure brevity in your answer.  0.97. What is the ratio of the Net enrolment rate(%) of East Asia (developing only) in 1993 to that in 2006?
Ensure brevity in your answer.  0.99. What is the ratio of the Net enrolment rate(%) of Heavily indebted poor countries in 1993 to that in 2006?
Offer a terse response. 0.66. What is the ratio of the Net enrolment rate(%) in Romania in 1993 to that in 2006?
Provide a short and direct response. 0.86. What is the ratio of the Net enrolment rate(%) of Uruguay in 1993 to that in 2006?
Keep it short and to the point. 0.95. What is the ratio of the Net enrolment rate(%) of East Asia (developing only) in 1994 to that in 1995?
Your answer should be very brief. 1.01. What is the ratio of the Net enrolment rate(%) in Heavily indebted poor countries in 1994 to that in 1995?
Provide a succinct answer. 0.96. What is the ratio of the Net enrolment rate(%) of Romania in 1994 to that in 1995?
Make the answer very short. 0.96. What is the ratio of the Net enrolment rate(%) of East Asia (developing only) in 1994 to that in 1996?
Your response must be concise. 1.02. What is the ratio of the Net enrolment rate(%) of Heavily indebted poor countries in 1994 to that in 1996?
Provide a succinct answer. 0.96. What is the ratio of the Net enrolment rate(%) in Romania in 1994 to that in 1996?
Make the answer very short. 0.97. What is the ratio of the Net enrolment rate(%) of Uruguay in 1994 to that in 1996?
Offer a very short reply. 1.01. What is the ratio of the Net enrolment rate(%) in Heavily indebted poor countries in 1994 to that in 1997?
Provide a succinct answer. 0.91. What is the ratio of the Net enrolment rate(%) in Romania in 1994 to that in 1997?
Offer a terse response. 0.98. What is the ratio of the Net enrolment rate(%) of Uruguay in 1994 to that in 1997?
Provide a succinct answer. 1.01. What is the ratio of the Net enrolment rate(%) in East Asia (developing only) in 1994 to that in 2005?
Keep it short and to the point. 0.97. What is the ratio of the Net enrolment rate(%) in Heavily indebted poor countries in 1994 to that in 2005?
Ensure brevity in your answer.  0.69. What is the ratio of the Net enrolment rate(%) of Romania in 1994 to that in 2005?
Offer a terse response. 0.91. What is the ratio of the Net enrolment rate(%) of Uruguay in 1994 to that in 2005?
Offer a terse response. 0.96. What is the ratio of the Net enrolment rate(%) of East Asia (developing only) in 1994 to that in 2006?
Provide a short and direct response. 0.97. What is the ratio of the Net enrolment rate(%) of Heavily indebted poor countries in 1994 to that in 2006?
Make the answer very short. 0.67. What is the ratio of the Net enrolment rate(%) in Romania in 1994 to that in 2006?
Your answer should be very brief. 0.94. What is the ratio of the Net enrolment rate(%) in Uruguay in 1994 to that in 2006?
Keep it short and to the point. 0.93. What is the ratio of the Net enrolment rate(%) in East Asia (developing only) in 1995 to that in 1996?
Provide a short and direct response. 1.01. What is the ratio of the Net enrolment rate(%) in East Asia (developing only) in 1995 to that in 1997?
Your answer should be compact. 1.01. What is the ratio of the Net enrolment rate(%) of Heavily indebted poor countries in 1995 to that in 1997?
Your answer should be very brief. 0.95. What is the ratio of the Net enrolment rate(%) in Romania in 1995 to that in 1997?
Provide a succinct answer. 1.02. What is the ratio of the Net enrolment rate(%) in East Asia (developing only) in 1995 to that in 2005?
Offer a terse response. 0.96. What is the ratio of the Net enrolment rate(%) in Heavily indebted poor countries in 1995 to that in 2005?
Your response must be concise. 0.72. What is the ratio of the Net enrolment rate(%) of Romania in 1995 to that in 2005?
Keep it short and to the point. 0.95. What is the ratio of the Net enrolment rate(%) of Uruguay in 1995 to that in 2005?
Keep it short and to the point. 0.95. What is the ratio of the Net enrolment rate(%) in East Asia (developing only) in 1995 to that in 2006?
Ensure brevity in your answer.  0.96. What is the ratio of the Net enrolment rate(%) of Heavily indebted poor countries in 1995 to that in 2006?
Provide a succinct answer. 0.7. What is the ratio of the Net enrolment rate(%) in Uruguay in 1995 to that in 2006?
Provide a short and direct response. 0.93. What is the ratio of the Net enrolment rate(%) in East Asia (developing only) in 1996 to that in 1997?
Give a very brief answer. 1. What is the ratio of the Net enrolment rate(%) in Heavily indebted poor countries in 1996 to that in 1997?
Ensure brevity in your answer.  0.95. What is the ratio of the Net enrolment rate(%) of Romania in 1996 to that in 1997?
Make the answer very short. 1.02. What is the ratio of the Net enrolment rate(%) of East Asia (developing only) in 1996 to that in 2005?
Your answer should be very brief. 0.95. What is the ratio of the Net enrolment rate(%) in Heavily indebted poor countries in 1996 to that in 2005?
Make the answer very short. 0.72. What is the ratio of the Net enrolment rate(%) of Romania in 1996 to that in 2005?
Offer a terse response. 0.95. What is the ratio of the Net enrolment rate(%) of Uruguay in 1996 to that in 2005?
Give a very brief answer. 0.95. What is the ratio of the Net enrolment rate(%) in East Asia (developing only) in 1996 to that in 2006?
Keep it short and to the point. 0.96. What is the ratio of the Net enrolment rate(%) in Heavily indebted poor countries in 1996 to that in 2006?
Provide a short and direct response. 0.7. What is the ratio of the Net enrolment rate(%) of Romania in 1996 to that in 2006?
Offer a terse response. 0.97. What is the ratio of the Net enrolment rate(%) of Uruguay in 1996 to that in 2006?
Offer a very short reply. 0.92. What is the ratio of the Net enrolment rate(%) of East Asia (developing only) in 1997 to that in 2005?
Keep it short and to the point. 0.95. What is the ratio of the Net enrolment rate(%) of Heavily indebted poor countries in 1997 to that in 2005?
Your answer should be compact. 0.76. What is the ratio of the Net enrolment rate(%) in Romania in 1997 to that in 2005?
Offer a terse response. 0.93. What is the ratio of the Net enrolment rate(%) in Uruguay in 1997 to that in 2005?
Your response must be concise. 0.95. What is the ratio of the Net enrolment rate(%) of East Asia (developing only) in 1997 to that in 2006?
Your answer should be compact. 0.95. What is the ratio of the Net enrolment rate(%) in Heavily indebted poor countries in 1997 to that in 2006?
Your answer should be compact. 0.74. What is the ratio of the Net enrolment rate(%) of Romania in 1997 to that in 2006?
Your response must be concise. 0.96. What is the ratio of the Net enrolment rate(%) in Uruguay in 1997 to that in 2006?
Your answer should be compact. 0.92. What is the ratio of the Net enrolment rate(%) of Heavily indebted poor countries in 2005 to that in 2006?
Your answer should be compact. 0.97. What is the ratio of the Net enrolment rate(%) of Romania in 2005 to that in 2006?
Your answer should be compact. 1.03. What is the ratio of the Net enrolment rate(%) of Uruguay in 2005 to that in 2006?
Your answer should be compact. 0.98. What is the difference between the highest and the second highest Net enrolment rate(%) in East Asia (developing only)?
Keep it short and to the point. 0.24. What is the difference between the highest and the second highest Net enrolment rate(%) of Heavily indebted poor countries?
Provide a succinct answer. 2.29. What is the difference between the highest and the second highest Net enrolment rate(%) of Romania?
Ensure brevity in your answer.  2.72. What is the difference between the highest and the second highest Net enrolment rate(%) in Uruguay?
Make the answer very short. 2.36. What is the difference between the highest and the lowest Net enrolment rate(%) of East Asia (developing only)?
Your answer should be compact. 4.57. What is the difference between the highest and the lowest Net enrolment rate(%) in Heavily indebted poor countries?
Your answer should be very brief. 24.24. What is the difference between the highest and the lowest Net enrolment rate(%) in Romania?
Offer a very short reply. 16.05. What is the difference between the highest and the lowest Net enrolment rate(%) in Uruguay?
Make the answer very short. 7.67. 